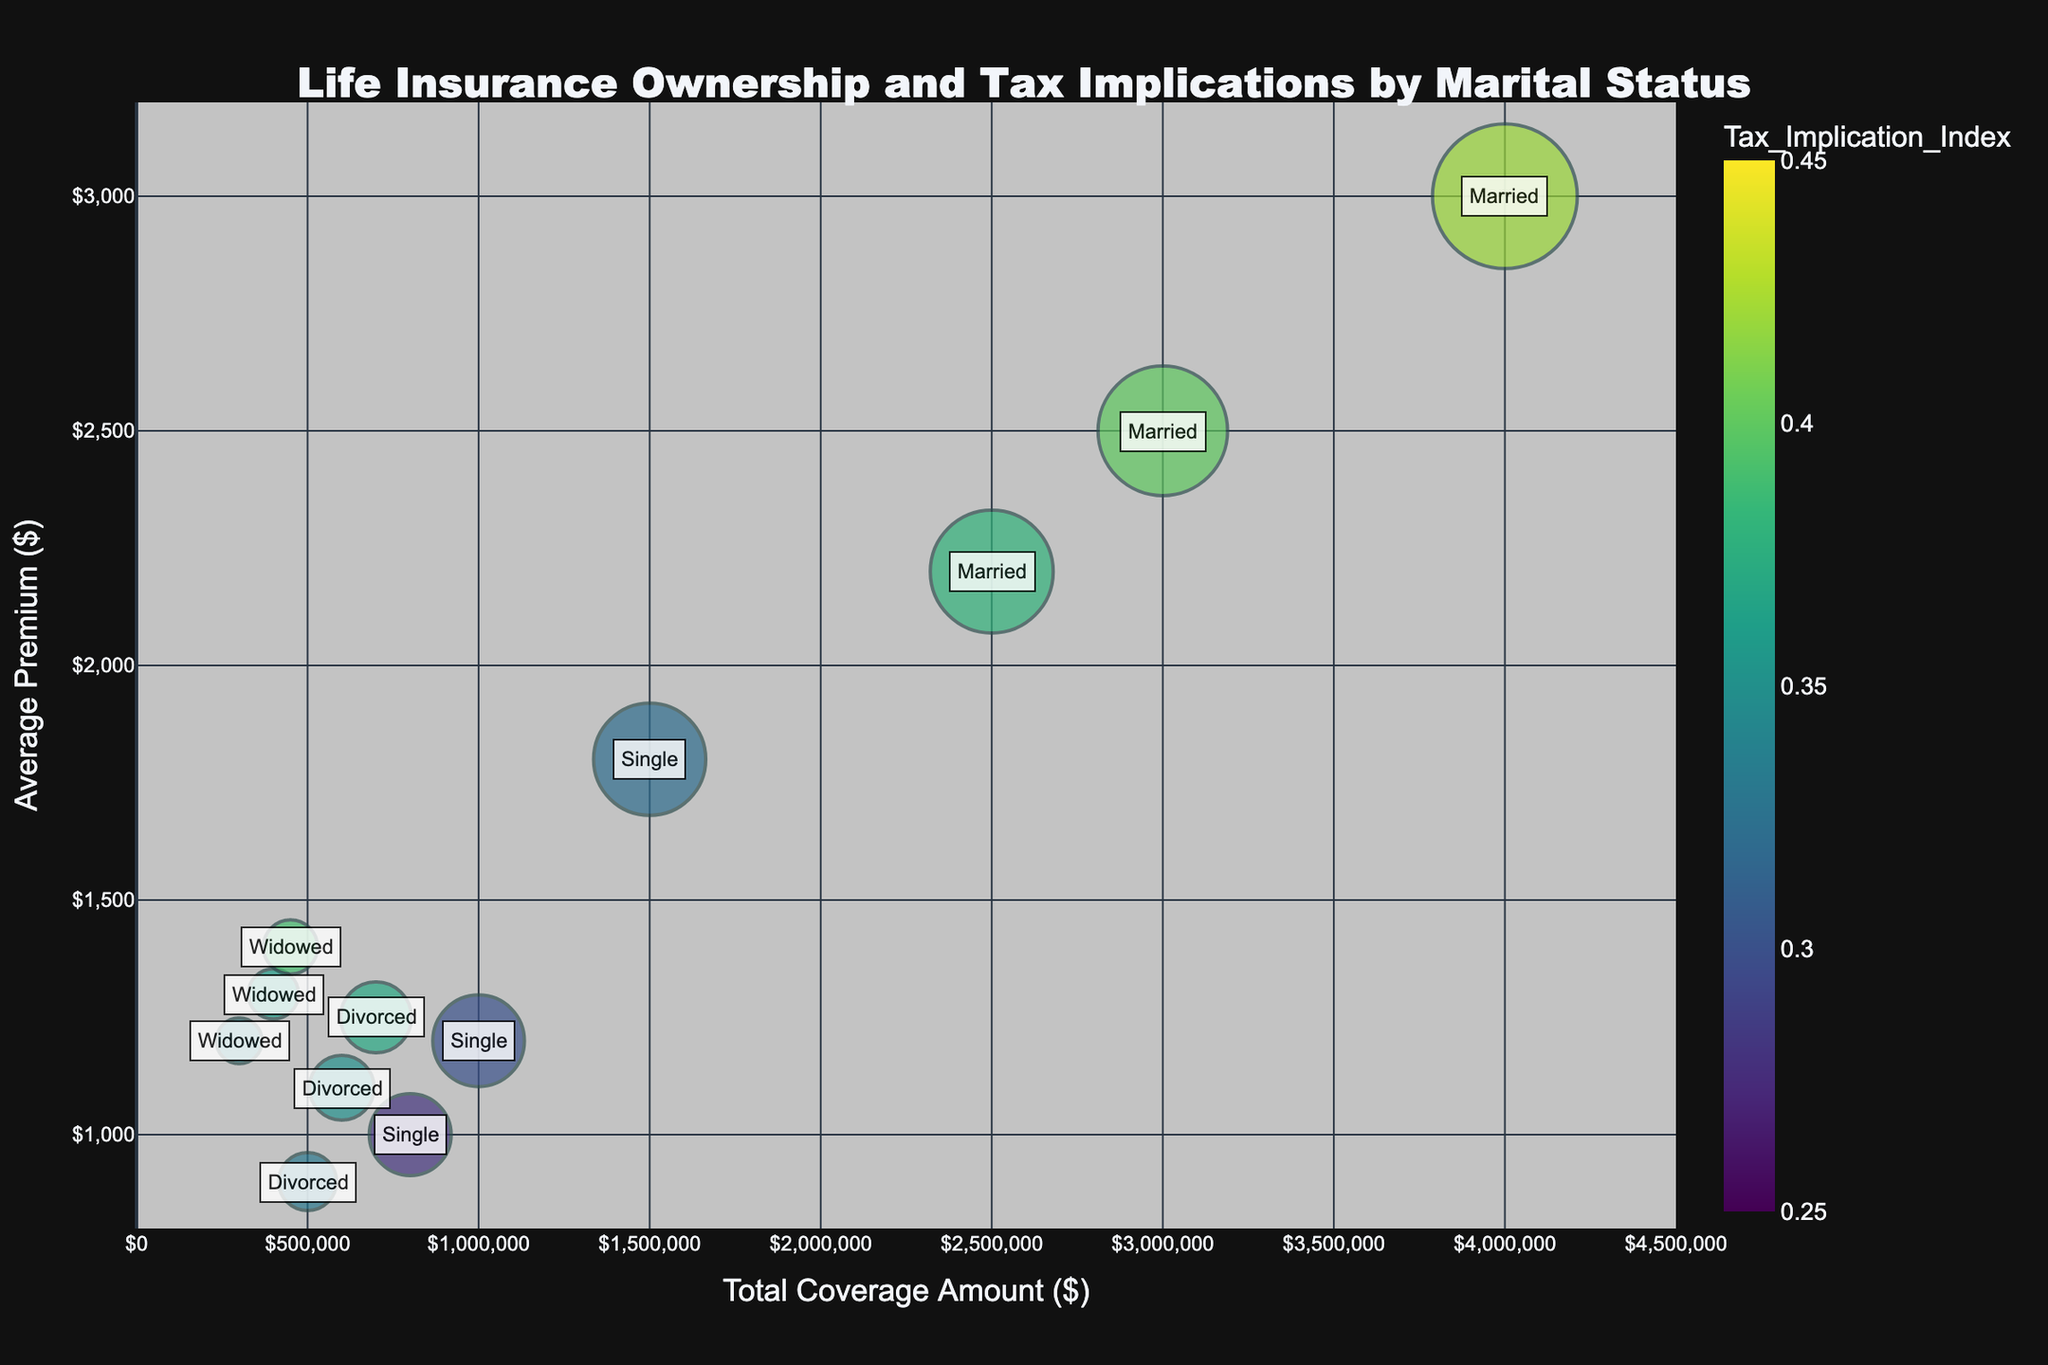What is the title of the bubble chart? The title of the chart is typically displayed at the top and clearly states the subject of the chart.
Answer: Life Insurance Ownership and Tax Implications by Marital Status How many data points are there for married individuals? By counting the bubbles specifically labeled as "Married", we can determine the number of data points.
Answer: 3 Which marital status has the highest tax implication index? By inspecting the color intensity of the bubbles, the one with the darkest color (highest Tax Implication Index) can be identified.
Answer: Married What is the total coverage amount for divorced individuals with the highest number of policies? Look for the bubble labeled 'Divorced' with the largest size (number of policies) and check its corresponding total coverage amount on the x-axis.
Answer: $700,000 What is the average premium for single individuals with 100 policies? Identify the bubble representing single individuals with 100 policies and read the value on the y-axis.
Answer: $1,200 Compare the total coverage amount between the bubbles with the highest and lowest average premiums. Which one is higher, and by how much? Identify the bubbles with the highest and lowest y-axis values (average premiums), then compare their corresponding x-axis values (total coverage amount). Subtract the lower value from the higher value to find the difference.
Answer: $4,000,000 - $300,000 = $3,700,000 Which group has the smallest number of life insurance policies? Find the smallest bubble on the chart and check its corresponding marital status label.
Answer: Widowed For married individuals, is there a correlation between the number of policies and the total coverage amount? Observing the bubbles for married individuals can reveal a pattern or trend in how the number of policies changes with the total coverage amount increases.
Answer: Yes, generally higher policies correlate with higher total coverage amounts Which marital status group shows the greatest variation in average premiums? Look for the marital status group with the widest range of y-axis values.
Answer: Married How does the total coverage amount for widowed individuals compare with the other groups? Assess the positions of bubbles labeled 'Widowed' on the x-axis relative to those of other groups.
Answer: Lower than other groups 